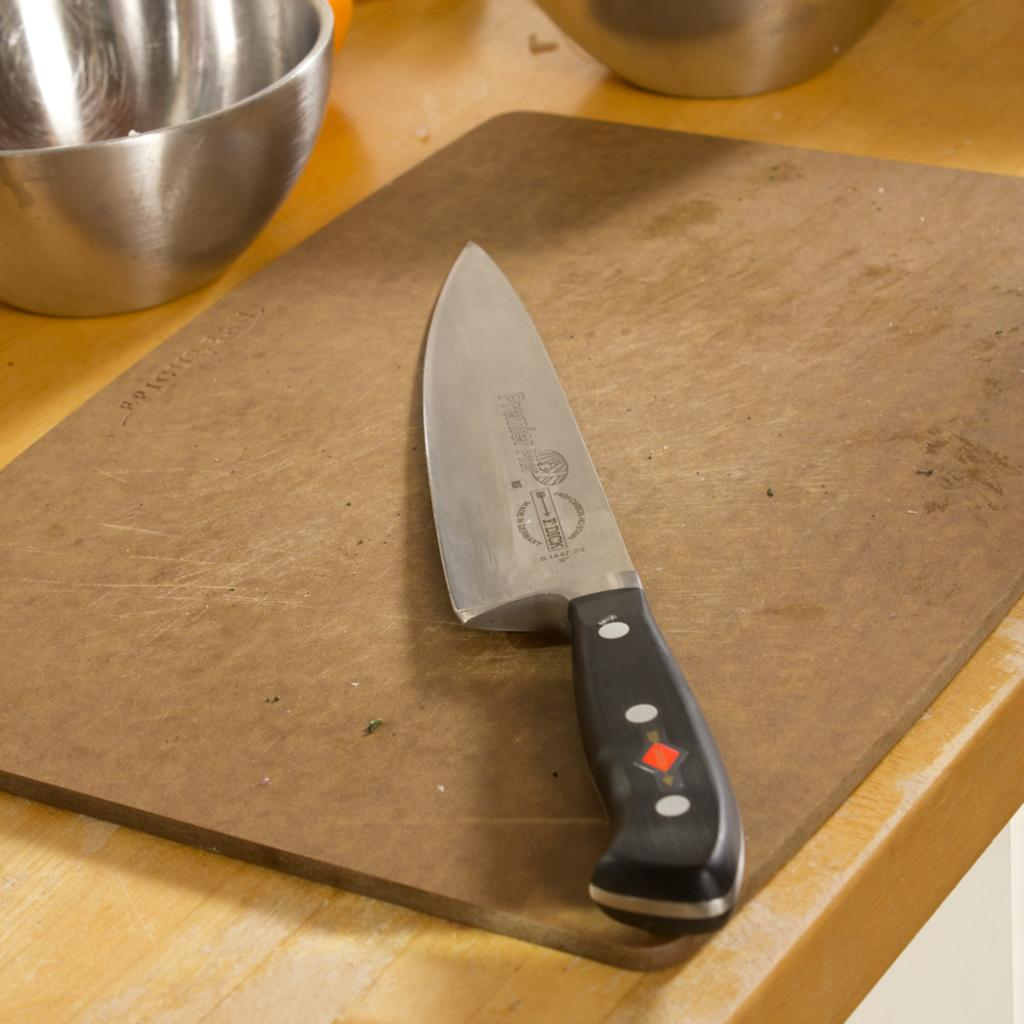What is placed on the chopping board in the image? There is a knife placed on a chopping board in the image. What objects are on the table in the image? There are two bowls on the table in the image. What piece of furniture is present in the image? The table is present in the image. What type of produce is being discussed in the image? There is no discussion or produce present in the image; it only features a knife on a chopping board and two bowls on a table. 